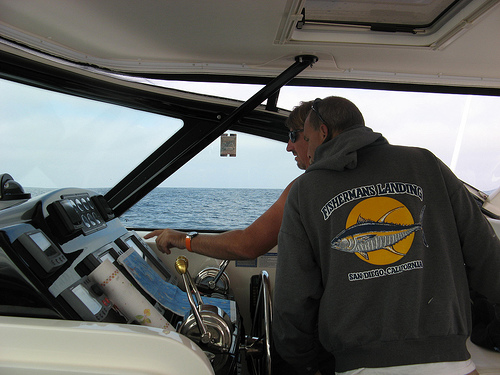<image>
Is there a watch on the man? No. The watch is not positioned on the man. They may be near each other, but the watch is not supported by or resting on top of the man. Where is the boat in relation to the water? Is it under the water? No. The boat is not positioned under the water. The vertical relationship between these objects is different. Is the pilot behind the screen? Yes. From this viewpoint, the pilot is positioned behind the screen, with the screen partially or fully occluding the pilot. 